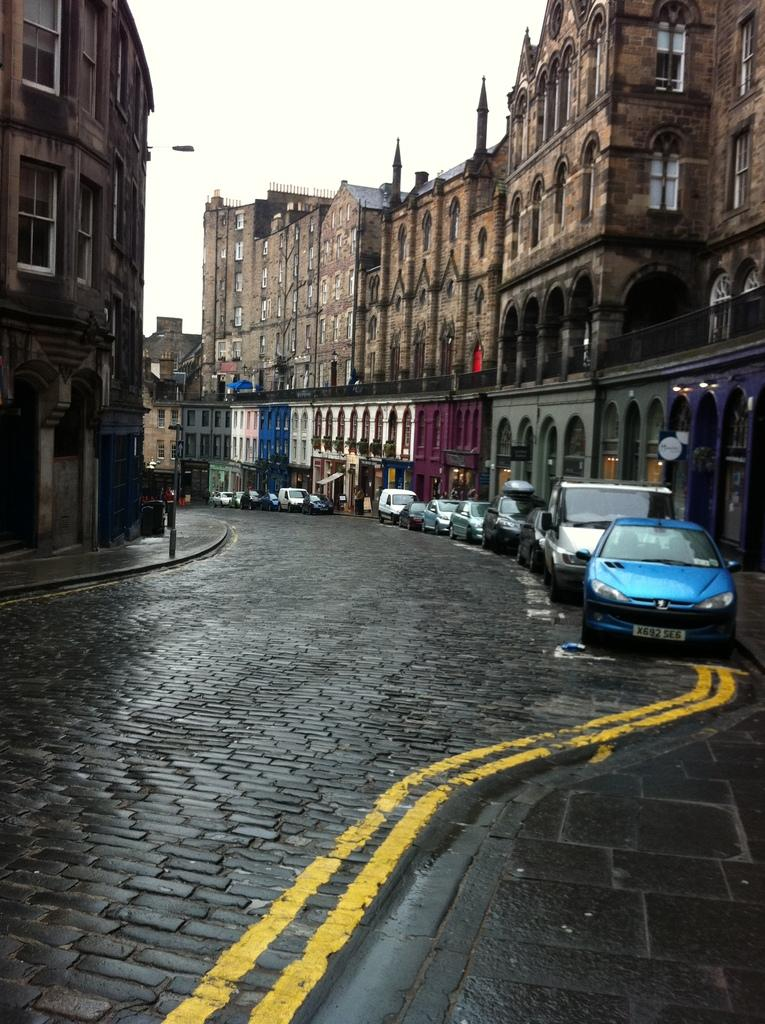Provide a one-sentence caption for the provided image. A blue car with a license plate that begins with X692 is parked at the curb. 